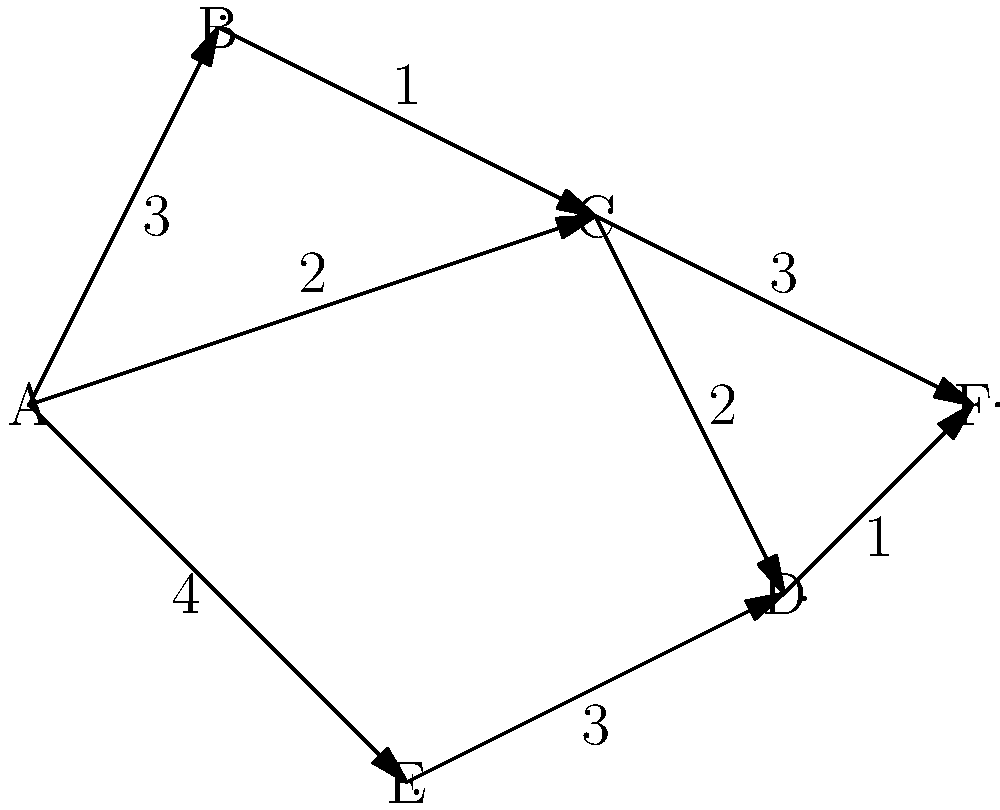In the given network diagram, find the shortest path from node A to node F. What is the total distance of this path? To find the shortest path from node A to node F, we need to consider all possible paths and their total distances. Let's break it down step-by-step:

1. Identify all possible paths from A to F:
   - A → B → C → F
   - A → B → C → D → F
   - A → C → F
   - A → C → D → F
   - A → E → D → F

2. Calculate the distance for each path:
   - A → B → C → F: 3 + 1 + 3 = 7
   - A → B → C → D → F: 3 + 1 + 2 + 1 = 7
   - A → C → F: 2 + 3 = 5
   - A → C → D → F: 2 + 2 + 1 = 5
   - A → E → D → F: 4 + 3 + 1 = 8

3. Compare the distances:
   The shortest paths are A → C → F and A → C → D → F, both with a total distance of 5.

4. Choose the path with fewer nodes:
   A → C → F has fewer nodes and is therefore the optimal shortest path.

Thus, the shortest path from A to F is A → C → F, with a total distance of 5.
Answer: 5 